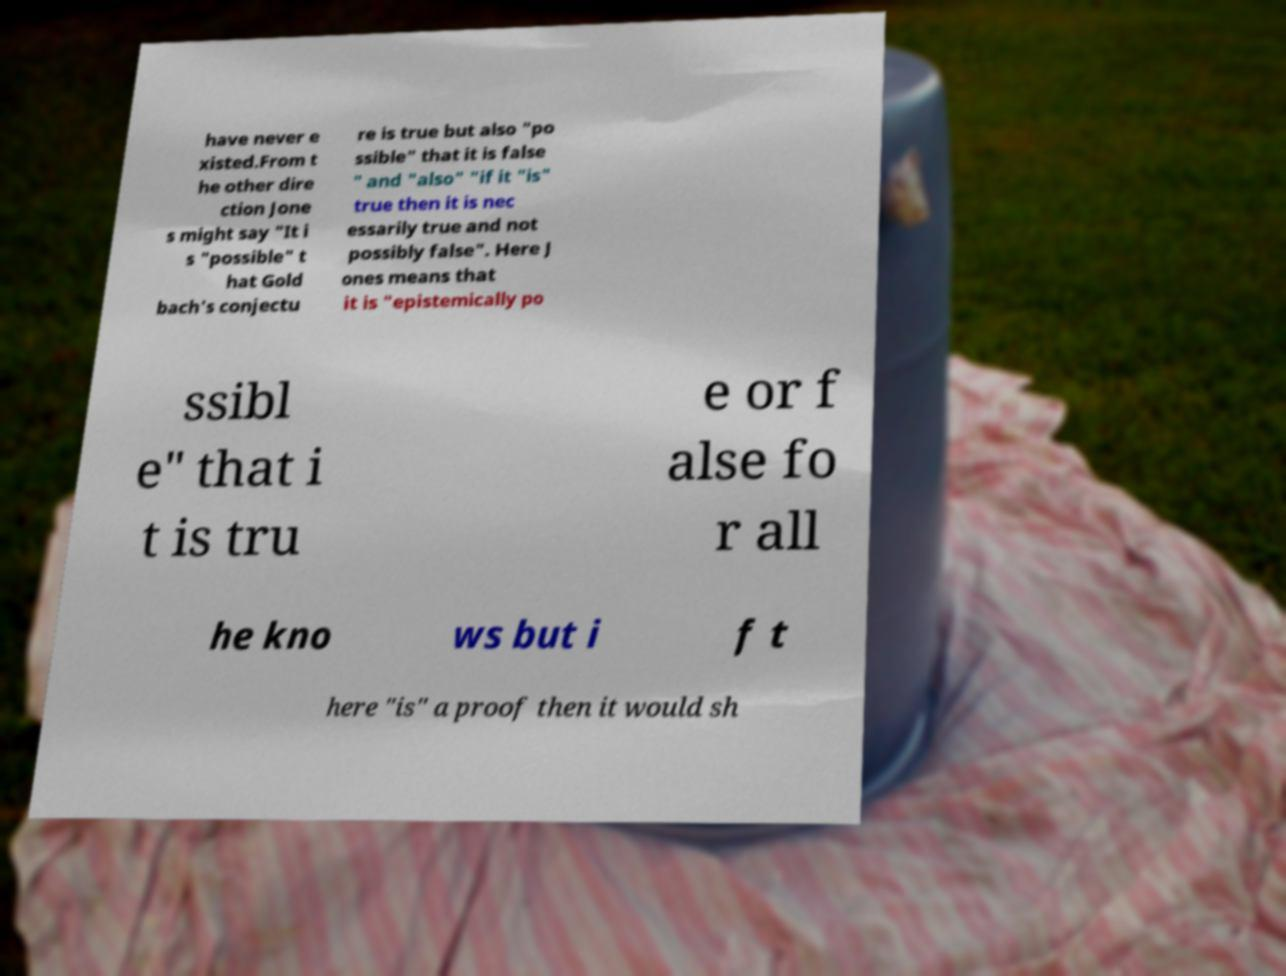I need the written content from this picture converted into text. Can you do that? have never e xisted.From t he other dire ction Jone s might say "It i s "possible" t hat Gold bach's conjectu re is true but also "po ssible" that it is false " and "also" "if it "is" true then it is nec essarily true and not possibly false". Here J ones means that it is "epistemically po ssibl e" that i t is tru e or f alse fo r all he kno ws but i f t here "is" a proof then it would sh 